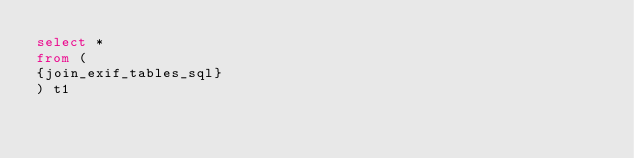<code> <loc_0><loc_0><loc_500><loc_500><_SQL_>select *
from (
{join_exif_tables_sql}
) t1
</code> 